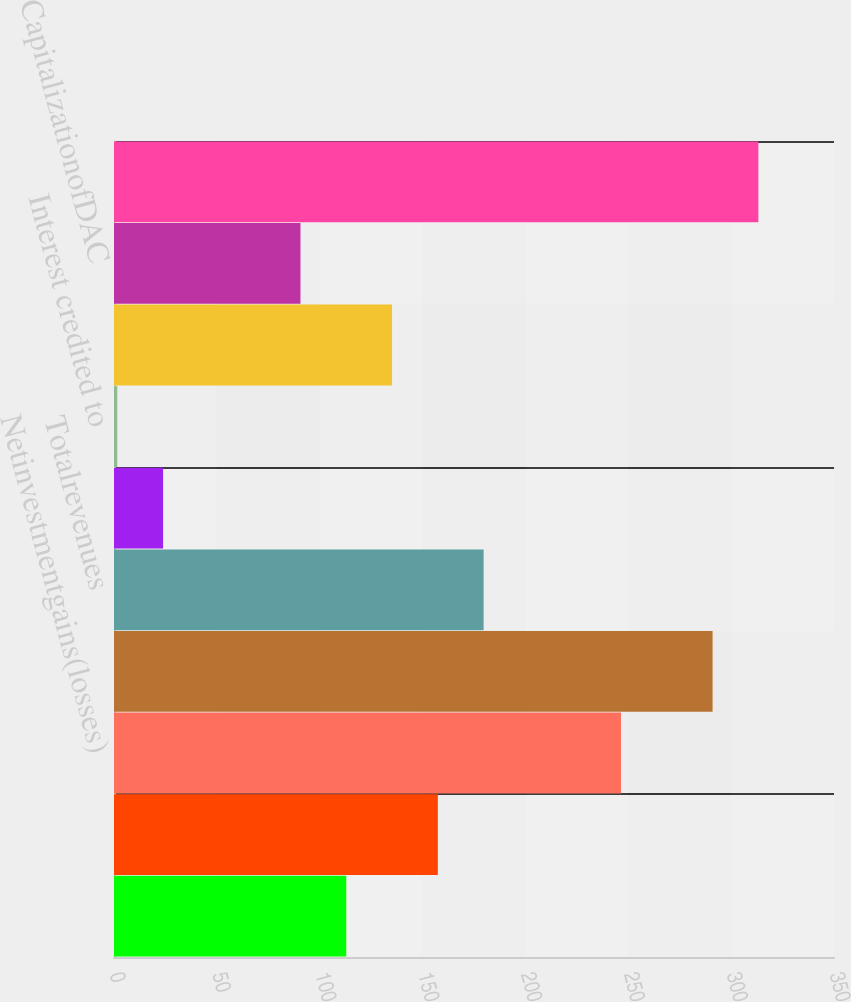<chart> <loc_0><loc_0><loc_500><loc_500><bar_chart><ecel><fcel>Netinvestmentincome<fcel>Netinvestmentgains(losses)<fcel>Netderivativegains(losses)<fcel>Totalrevenues<fcel>Policyholder benefits and<fcel>Interest credited to<fcel>Interestcreditedtobankdeposits<fcel>CapitalizationofDAC<fcel>AmortizationofDACandVOBA<nl><fcel>112.9<fcel>157.42<fcel>246.46<fcel>290.98<fcel>179.68<fcel>23.86<fcel>1.6<fcel>135.16<fcel>90.64<fcel>313.24<nl></chart> 